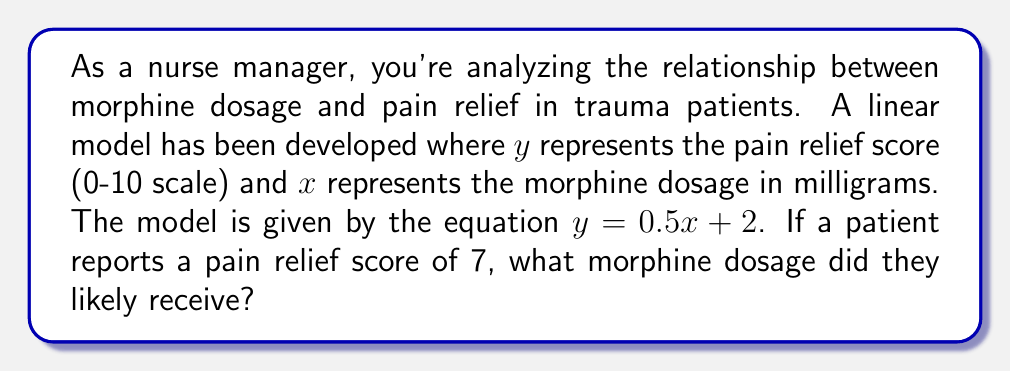Could you help me with this problem? To solve this problem, we'll use the given linear equation and work backwards to find the dosage:

1) The linear equation is $y = 0.5x + 2$, where:
   $y$ = pain relief score
   $x$ = morphine dosage in mg

2) We're given that the patient's pain relief score (y) is 7. Let's substitute this into the equation:
   $7 = 0.5x + 2$

3) To isolate x, first subtract 2 from both sides:
   $7 - 2 = 0.5x + 2 - 2$
   $5 = 0.5x$

4) Now, divide both sides by 0.5:
   $\frac{5}{0.5} = \frac{0.5x}{0.5}$
   $10 = x$

Therefore, the patient likely received a 10 mg dose of morphine.
Answer: 10 mg 